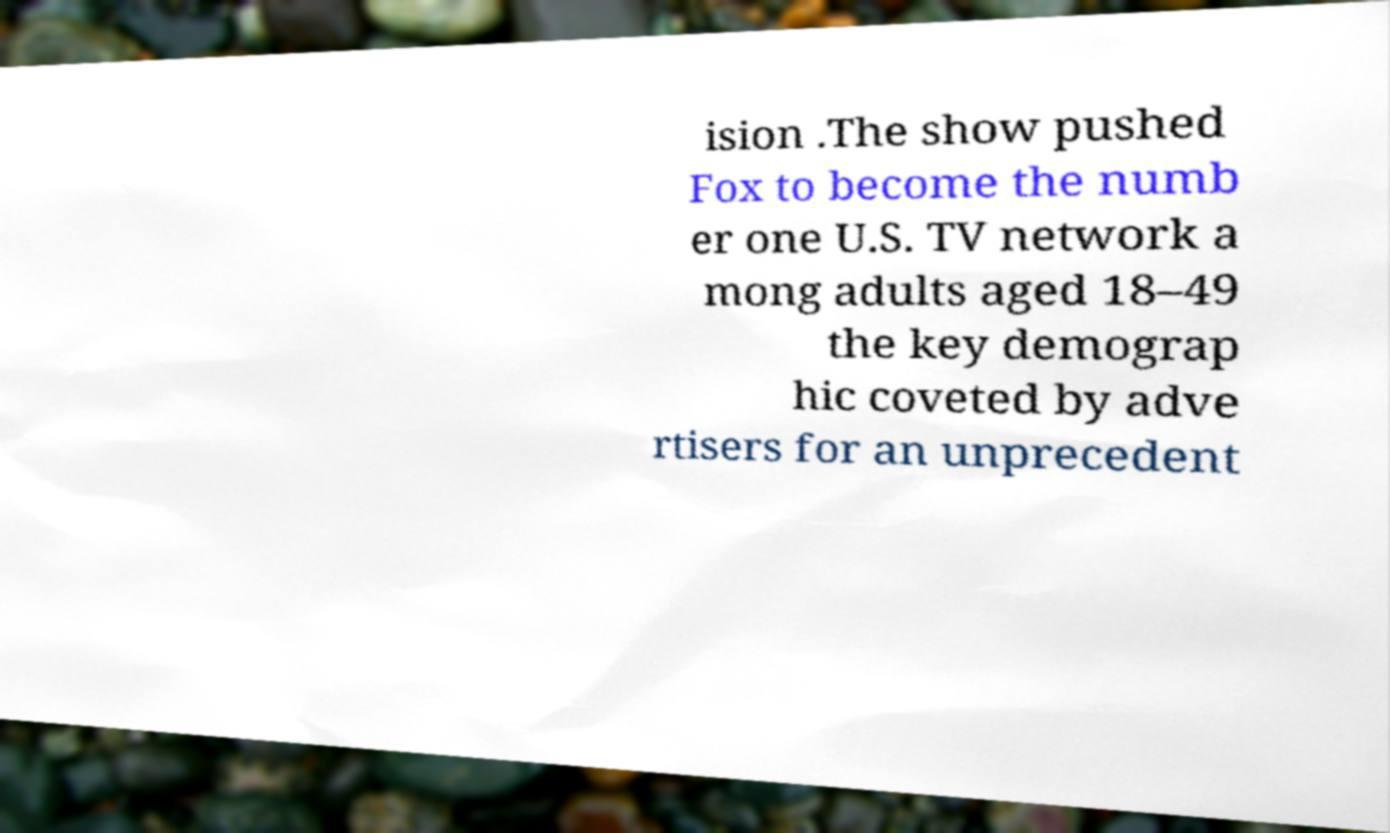I need the written content from this picture converted into text. Can you do that? ision .The show pushed Fox to become the numb er one U.S. TV network a mong adults aged 18–49 the key demograp hic coveted by adve rtisers for an unprecedent 